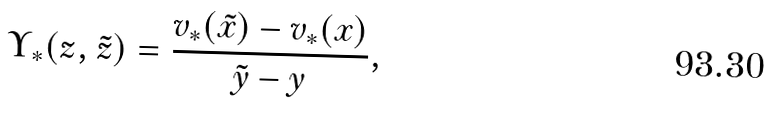<formula> <loc_0><loc_0><loc_500><loc_500>\Upsilon _ { * } ( z , \tilde { z } ) = \frac { v _ { * } ( \tilde { x } ) - v _ { * } ( x ) } { \tilde { y } - y } ,</formula> 